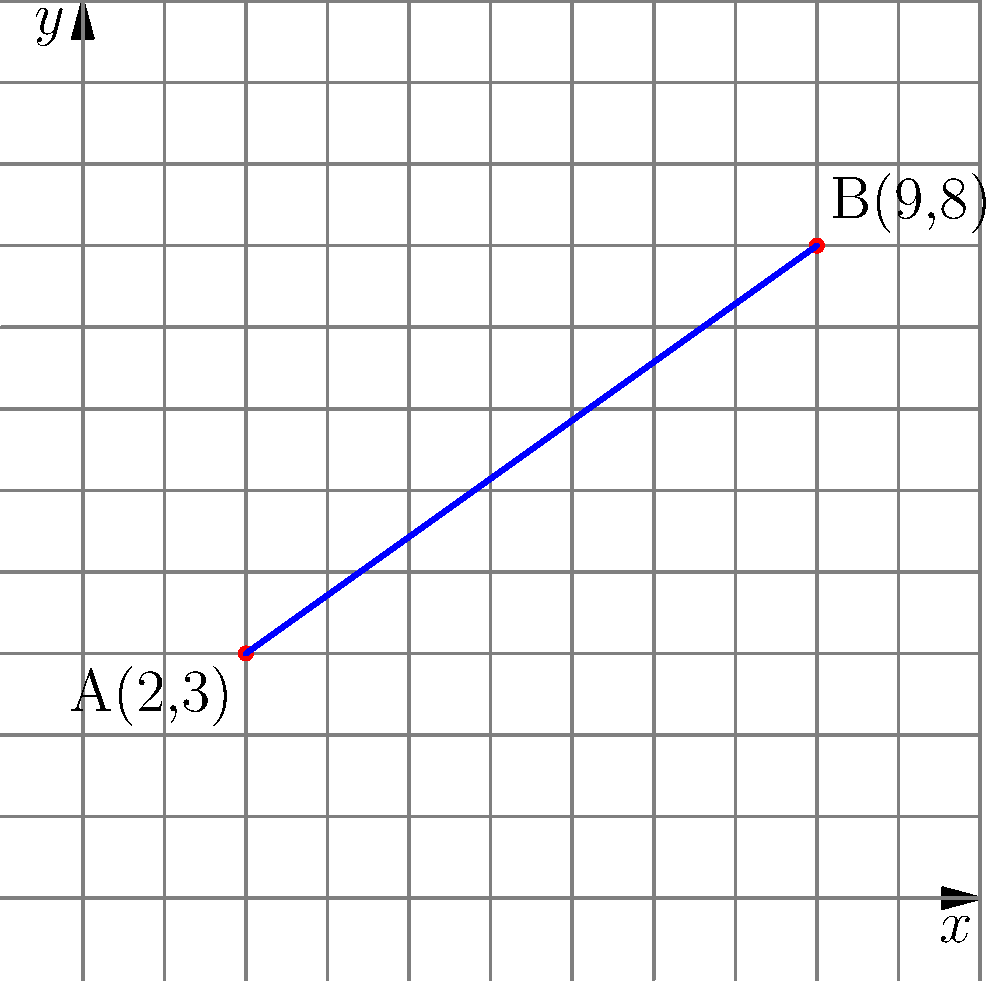In honor of your cousin's brave actions, you want to calculate the distance they traveled. On a coordinate plane, their starting point is represented by A(2,3) and their destination is represented by B(9,8). Calculate the distance between these two points to determine the length of their courageous journey. To calculate the distance between two points on a coordinate plane, we use the distance formula:

$$ d = \sqrt{(x_2 - x_1)^2 + (y_2 - y_1)^2} $$

Where $(x_1, y_1)$ are the coordinates of the first point and $(x_2, y_2)$ are the coordinates of the second point.

Given:
- Point A: $(x_1, y_1) = (2, 3)$
- Point B: $(x_2, y_2) = (9, 8)$

Step 1: Substitute the values into the distance formula:
$$ d = \sqrt{(9 - 2)^2 + (8 - 3)^2} $$

Step 2: Simplify the expressions inside the parentheses:
$$ d = \sqrt{7^2 + 5^2} $$

Step 3: Calculate the squares:
$$ d = \sqrt{49 + 25} $$

Step 4: Add the values under the square root:
$$ d = \sqrt{74} $$

Step 5: Simplify the square root:
$$ d = \sqrt{74} \approx 8.60 $$

Therefore, the distance between points A and B, representing your cousin's brave journey, is approximately 8.60 units.
Answer: $\sqrt{74}$ or approximately 8.60 units 